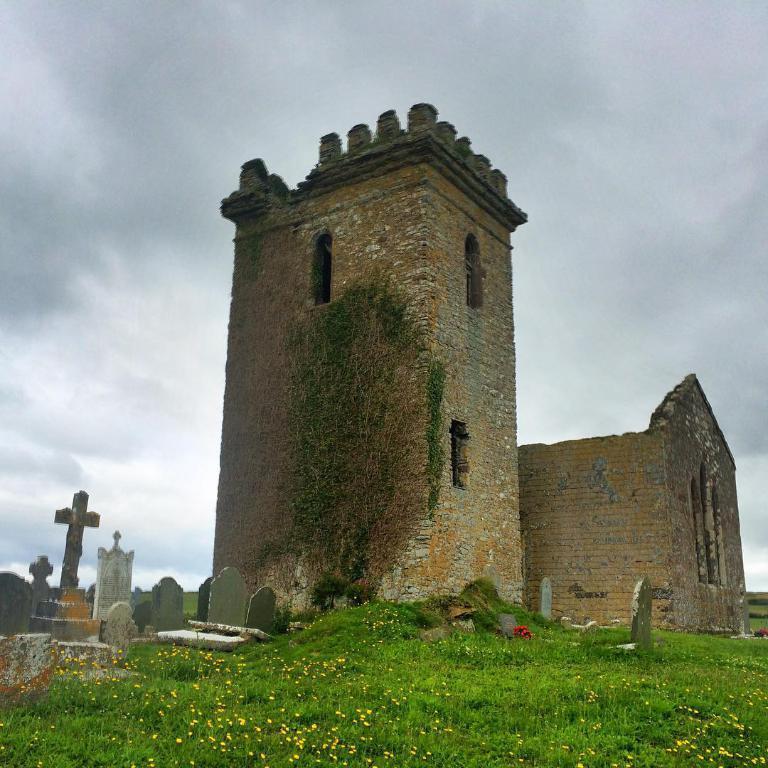Could you give a brief overview of what you see in this image? In this picture I can observe a monument. There is a graveyard beside the monument. I can observe some grass on the ground. In the background there is a sky with some clouds. 